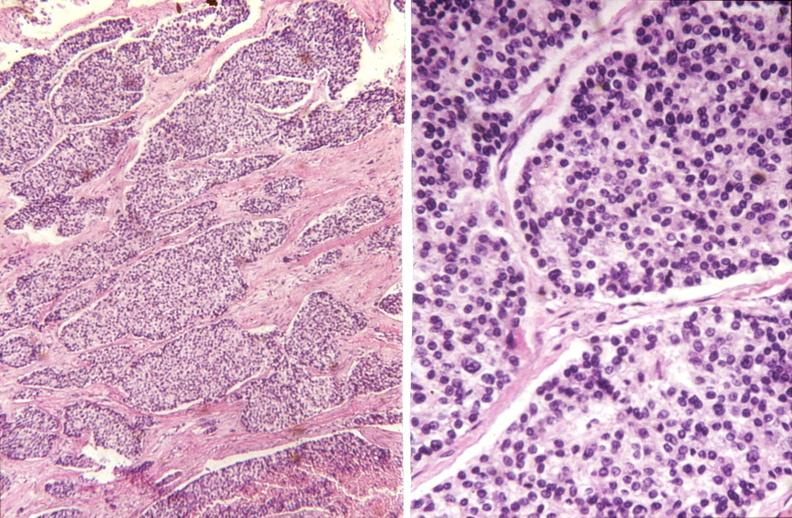does this image show parathyroid, carcinoma?
Answer the question using a single word or phrase. Yes 